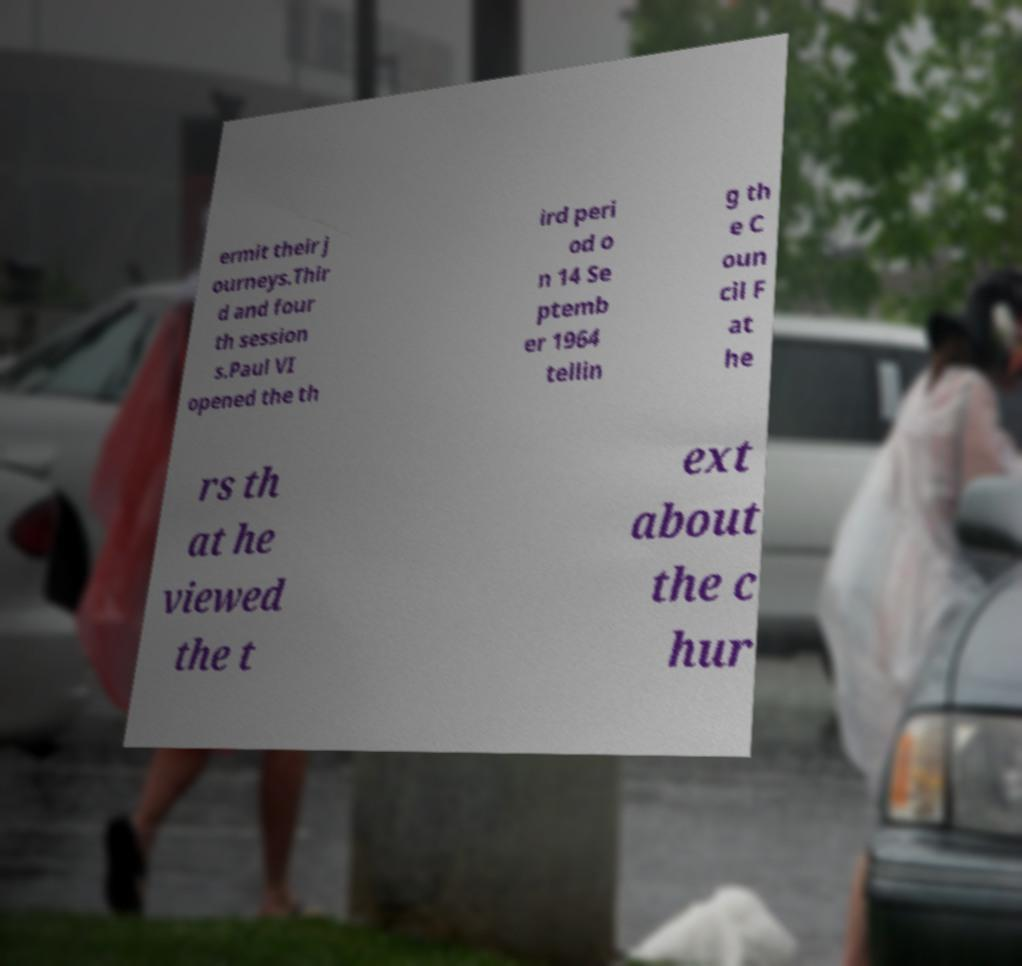Could you assist in decoding the text presented in this image and type it out clearly? ermit their j ourneys.Thir d and four th session s.Paul VI opened the th ird peri od o n 14 Se ptemb er 1964 tellin g th e C oun cil F at he rs th at he viewed the t ext about the c hur 